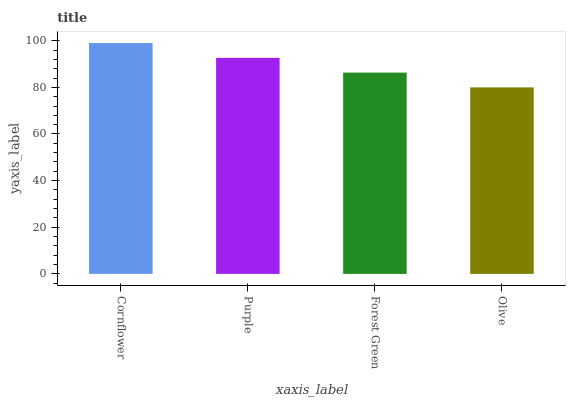Is Purple the minimum?
Answer yes or no. No. Is Purple the maximum?
Answer yes or no. No. Is Cornflower greater than Purple?
Answer yes or no. Yes. Is Purple less than Cornflower?
Answer yes or no. Yes. Is Purple greater than Cornflower?
Answer yes or no. No. Is Cornflower less than Purple?
Answer yes or no. No. Is Purple the high median?
Answer yes or no. Yes. Is Forest Green the low median?
Answer yes or no. Yes. Is Cornflower the high median?
Answer yes or no. No. Is Olive the low median?
Answer yes or no. No. 